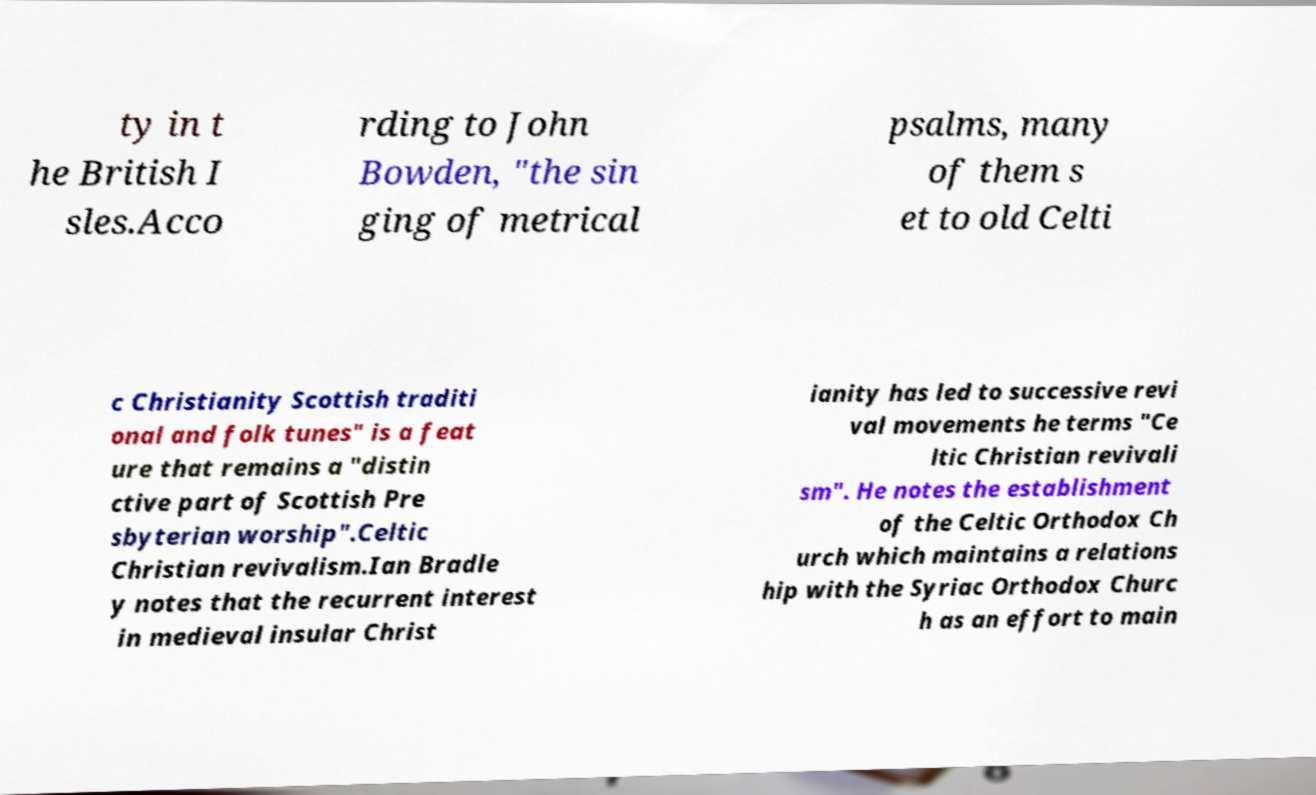There's text embedded in this image that I need extracted. Can you transcribe it verbatim? ty in t he British I sles.Acco rding to John Bowden, "the sin ging of metrical psalms, many of them s et to old Celti c Christianity Scottish traditi onal and folk tunes" is a feat ure that remains a "distin ctive part of Scottish Pre sbyterian worship".Celtic Christian revivalism.Ian Bradle y notes that the recurrent interest in medieval insular Christ ianity has led to successive revi val movements he terms "Ce ltic Christian revivali sm". He notes the establishment of the Celtic Orthodox Ch urch which maintains a relations hip with the Syriac Orthodox Churc h as an effort to main 